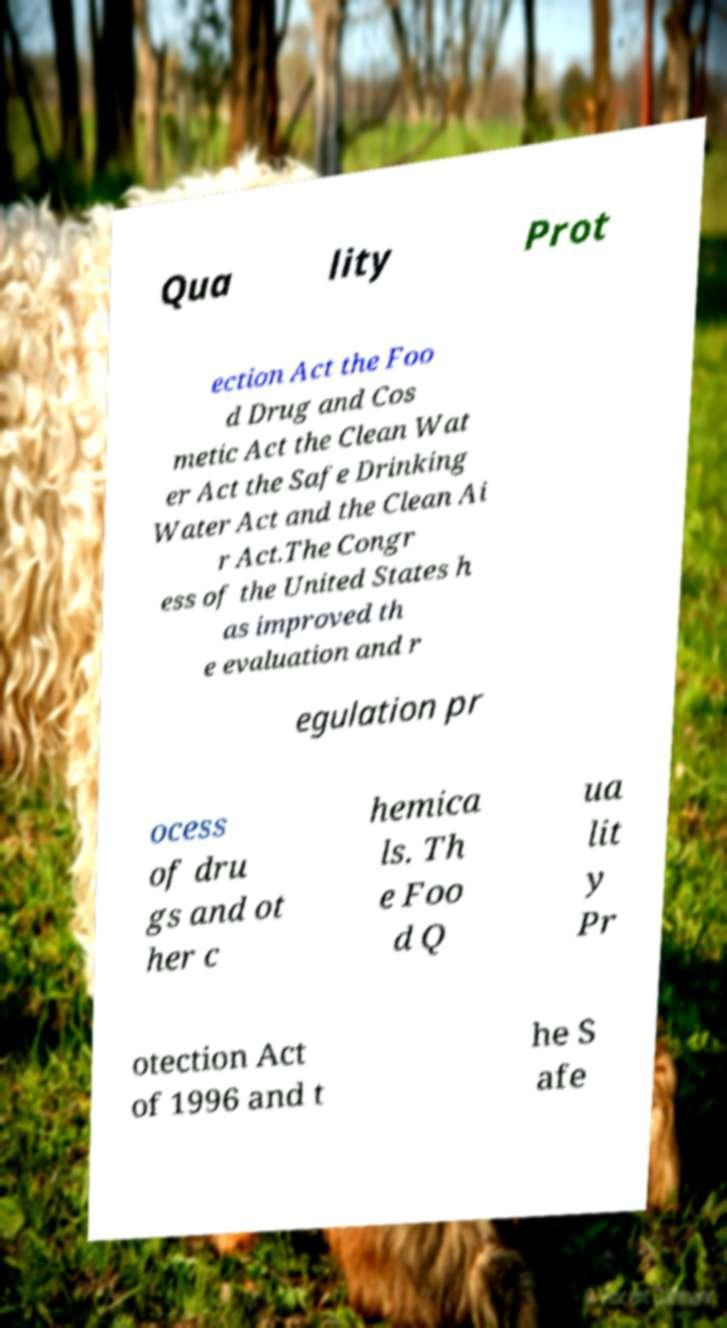I need the written content from this picture converted into text. Can you do that? Qua lity Prot ection Act the Foo d Drug and Cos metic Act the Clean Wat er Act the Safe Drinking Water Act and the Clean Ai r Act.The Congr ess of the United States h as improved th e evaluation and r egulation pr ocess of dru gs and ot her c hemica ls. Th e Foo d Q ua lit y Pr otection Act of 1996 and t he S afe 